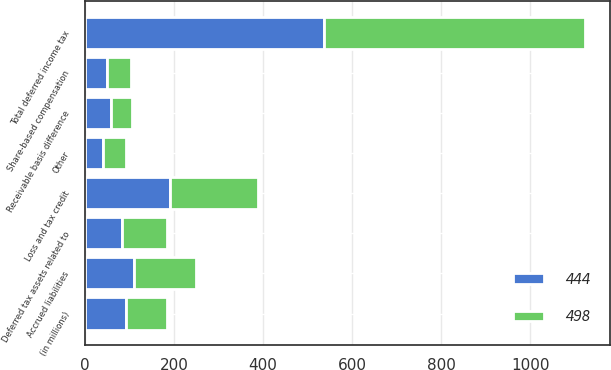<chart> <loc_0><loc_0><loc_500><loc_500><stacked_bar_chart><ecel><fcel>(in millions)<fcel>Receivable basis difference<fcel>Accrued liabilities<fcel>Share-based compensation<fcel>Loss and tax credit<fcel>Deferred tax assets related to<fcel>Other<fcel>Total deferred income tax<nl><fcel>498<fcel>92<fcel>47<fcel>138<fcel>53<fcel>197<fcel>100<fcel>50<fcel>585<nl><fcel>444<fcel>92<fcel>59<fcel>111<fcel>51<fcel>191<fcel>84<fcel>42<fcel>538<nl></chart> 